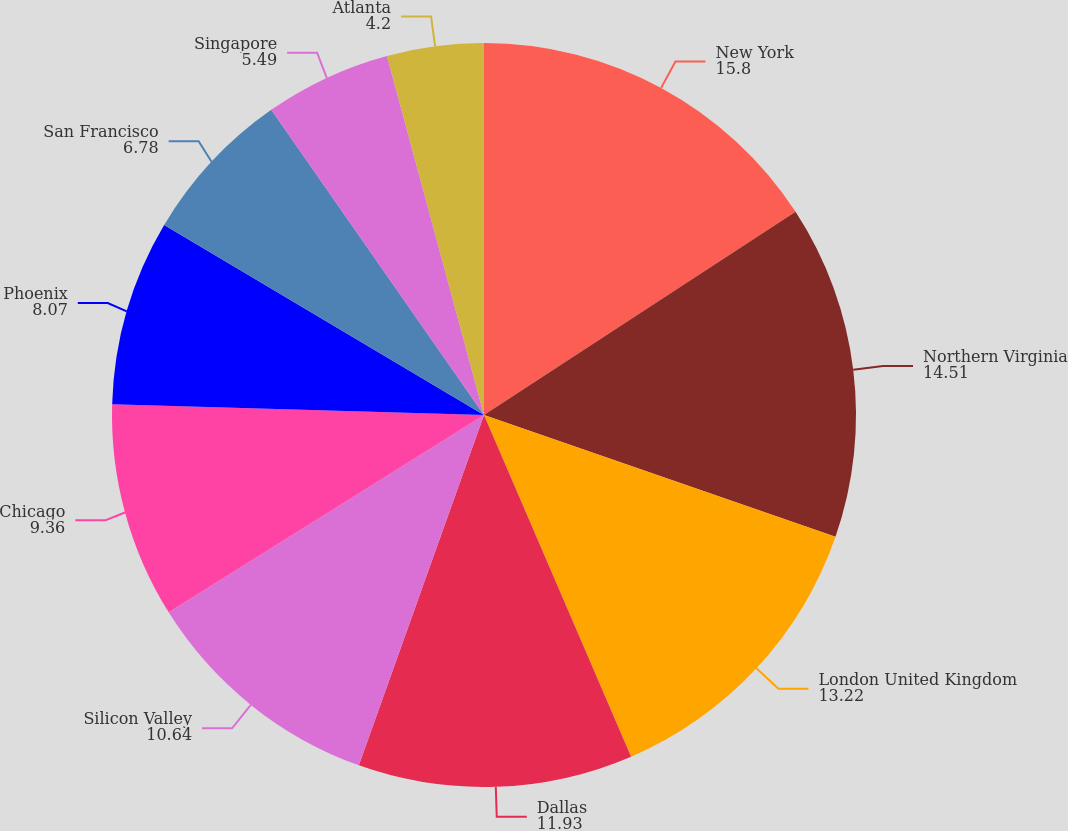<chart> <loc_0><loc_0><loc_500><loc_500><pie_chart><fcel>New York<fcel>Northern Virginia<fcel>London United Kingdom<fcel>Dallas<fcel>Silicon Valley<fcel>Chicago<fcel>Phoenix<fcel>San Francisco<fcel>Singapore<fcel>Atlanta<nl><fcel>15.8%<fcel>14.51%<fcel>13.22%<fcel>11.93%<fcel>10.64%<fcel>9.36%<fcel>8.07%<fcel>6.78%<fcel>5.49%<fcel>4.2%<nl></chart> 